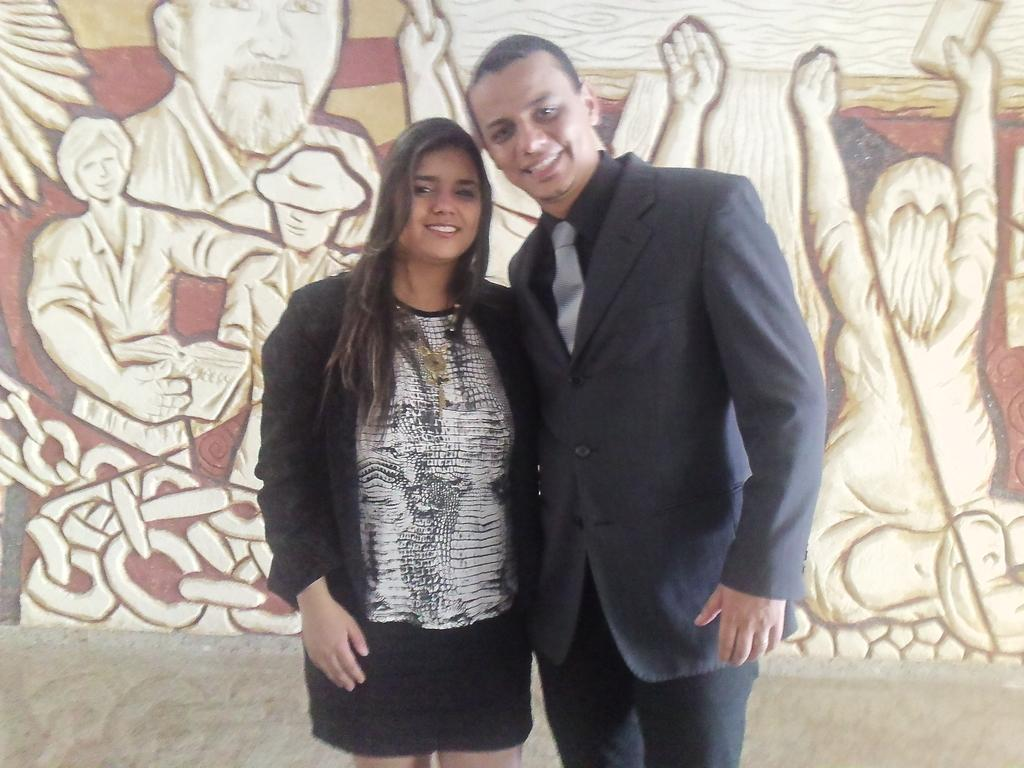How many people are in the image? There are two persons in the image: a man and a woman. What is the man wearing? The man is wearing a blue suit. What is the woman wearing? The woman is wearing a black jacket. What can be seen on the wall in the background? There is an art piece on the wall in the background. What type of lip can be seen on the art piece in the image? There is no lip visible on the art piece in the image. How many heads are visible in the image? There are two heads visible in the image, belonging to the man and the woman. 